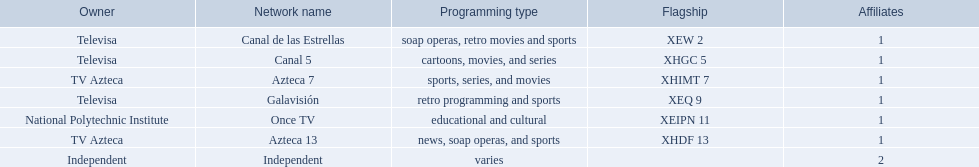I'm looking to parse the entire table for insights. Could you assist me with that? {'header': ['Owner', 'Network name', 'Programming type', 'Flagship', 'Affiliates'], 'rows': [['Televisa', 'Canal de las Estrellas', 'soap operas, retro movies and sports', 'XEW 2', '1'], ['Televisa', 'Canal 5', 'cartoons, movies, and series', 'XHGC 5', '1'], ['TV Azteca', 'Azteca 7', 'sports, series, and movies', 'XHIMT 7', '1'], ['Televisa', 'Galavisión', 'retro programming and sports', 'XEQ 9', '1'], ['National Polytechnic Institute', 'Once TV', 'educational and cultural', 'XEIPN 11', '1'], ['TV Azteca', 'Azteca 13', 'news, soap operas, and sports', 'XHDF 13', '1'], ['Independent', 'Independent', 'varies', '', '2']]} Which owner only owns one network? National Polytechnic Institute, Independent. Of those, what is the network name? Once TV, Independent. Of those, which programming type is educational and cultural? Once TV. 